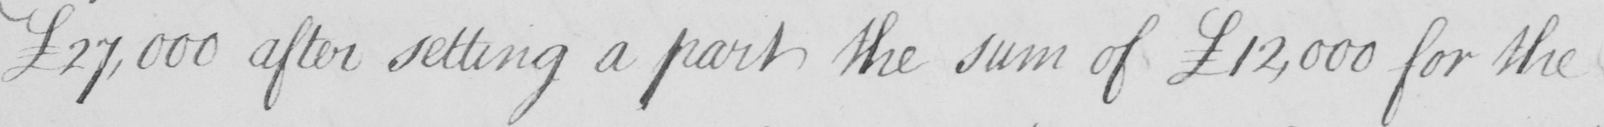Please transcribe the handwritten text in this image. £27,000 after setting a part the sum of  £12,000 for the 